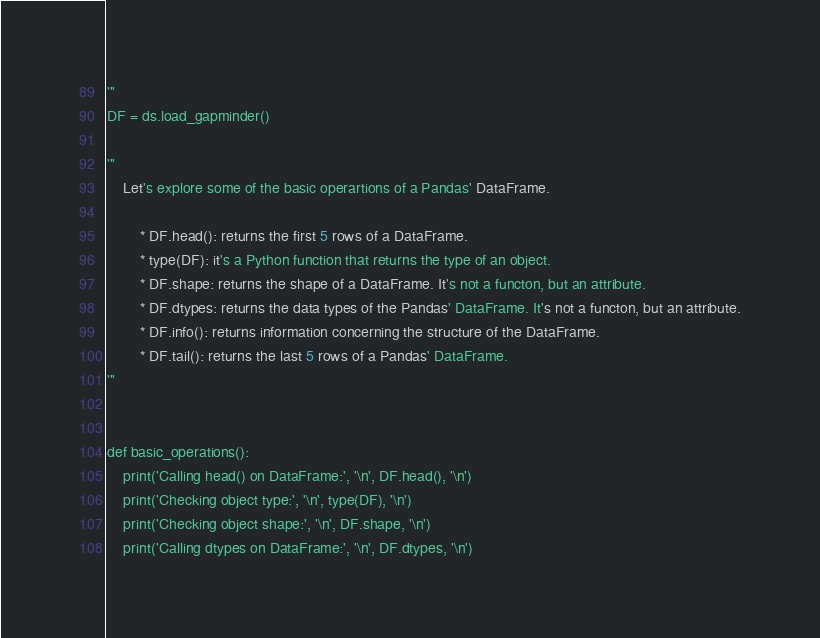Convert code to text. <code><loc_0><loc_0><loc_500><loc_500><_Python_>'''
DF = ds.load_gapminder()

'''
    Let's explore some of the basic operartions of a Pandas' DataFrame.
    
        * DF.head(): returns the first 5 rows of a DataFrame.
        * type(DF): it's a Python function that returns the type of an object.
        * DF.shape: returns the shape of a DataFrame. It's not a functon, but an attribute.
        * DF.dtypes: returns the data types of the Pandas' DataFrame. It's not a functon, but an attribute.
        * DF.info(): returns information concerning the structure of the DataFrame.
        * DF.tail(): returns the last 5 rows of a Pandas' DataFrame.
'''


def basic_operations():
    print('Calling head() on DataFrame:', '\n', DF.head(), '\n')
    print('Checking object type:', '\n', type(DF), '\n')
    print('Checking object shape:', '\n', DF.shape, '\n')
    print('Calling dtypes on DataFrame:', '\n', DF.dtypes, '\n')</code> 